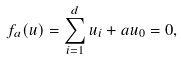Convert formula to latex. <formula><loc_0><loc_0><loc_500><loc_500>f _ { a } ( u ) = \sum _ { i = 1 } ^ { d } u _ { i } + a u _ { 0 } = 0 ,</formula> 